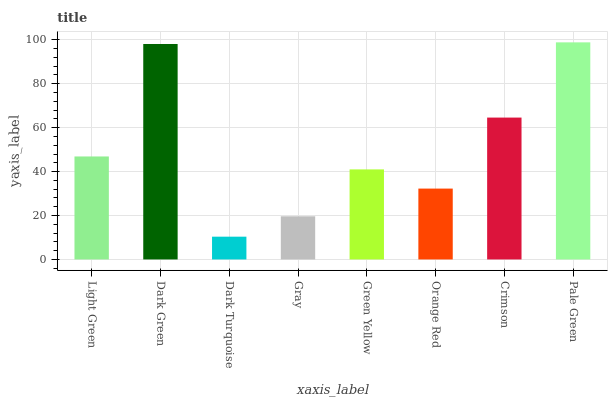Is Dark Turquoise the minimum?
Answer yes or no. Yes. Is Pale Green the maximum?
Answer yes or no. Yes. Is Dark Green the minimum?
Answer yes or no. No. Is Dark Green the maximum?
Answer yes or no. No. Is Dark Green greater than Light Green?
Answer yes or no. Yes. Is Light Green less than Dark Green?
Answer yes or no. Yes. Is Light Green greater than Dark Green?
Answer yes or no. No. Is Dark Green less than Light Green?
Answer yes or no. No. Is Light Green the high median?
Answer yes or no. Yes. Is Green Yellow the low median?
Answer yes or no. Yes. Is Dark Turquoise the high median?
Answer yes or no. No. Is Light Green the low median?
Answer yes or no. No. 